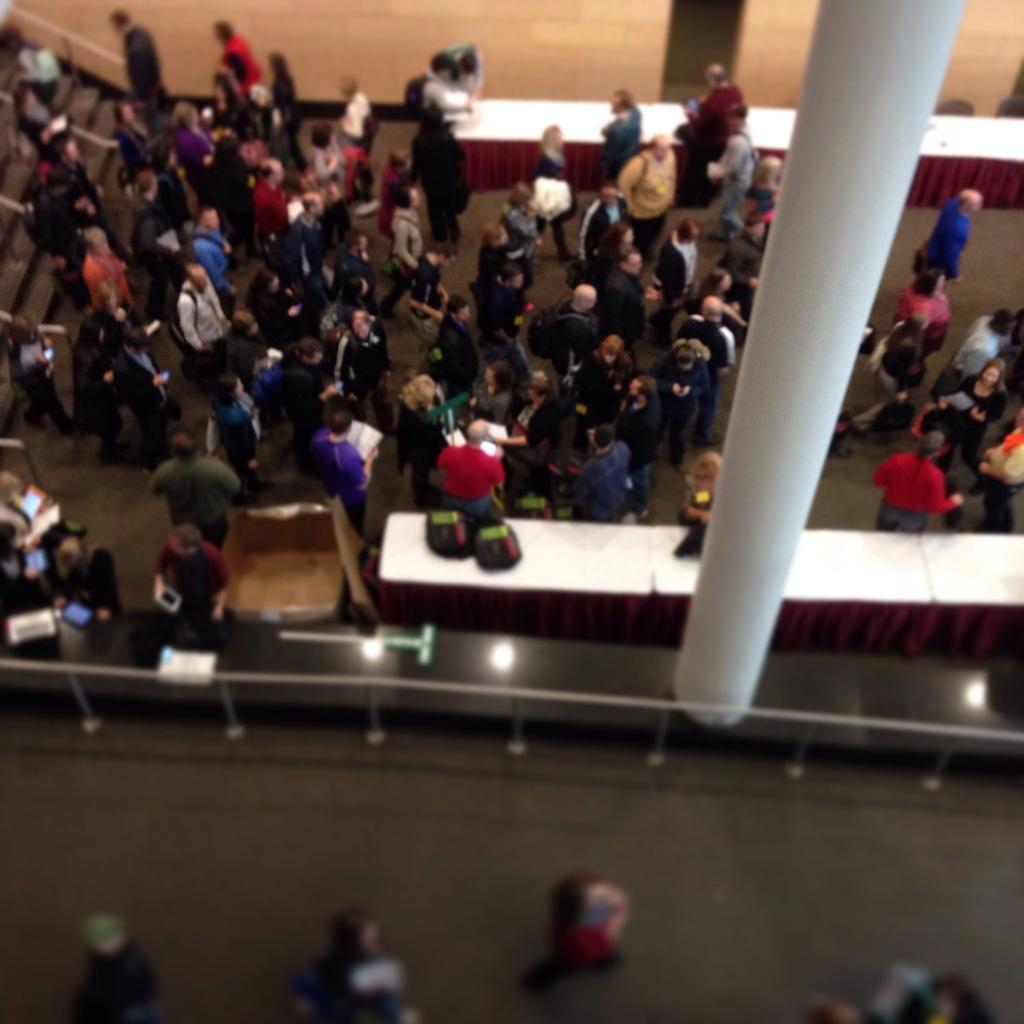Describe this image in one or two sentences. In this image, we can see some people walking, there is a white pillar, we can see two tables and there are some stairs on the left side. 